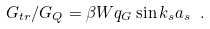<formula> <loc_0><loc_0><loc_500><loc_500>G _ { t r } / G _ { Q } = \beta W q _ { G } \sin k _ { s } a _ { s } \ .</formula> 